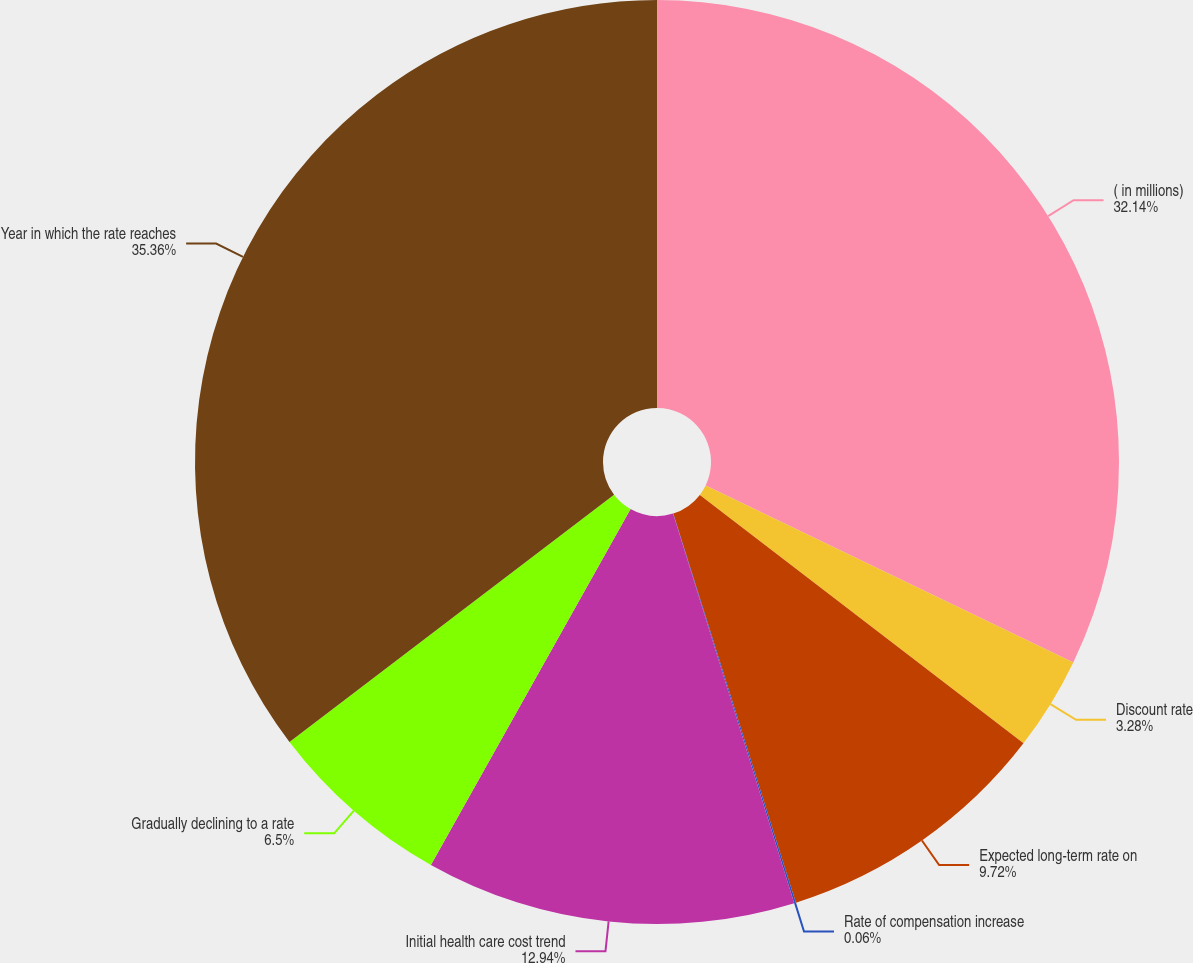Convert chart. <chart><loc_0><loc_0><loc_500><loc_500><pie_chart><fcel>( in millions)<fcel>Discount rate<fcel>Expected long-term rate on<fcel>Rate of compensation increase<fcel>Initial health care cost trend<fcel>Gradually declining to a rate<fcel>Year in which the rate reaches<nl><fcel>32.14%<fcel>3.28%<fcel>9.72%<fcel>0.06%<fcel>12.94%<fcel>6.5%<fcel>35.36%<nl></chart> 